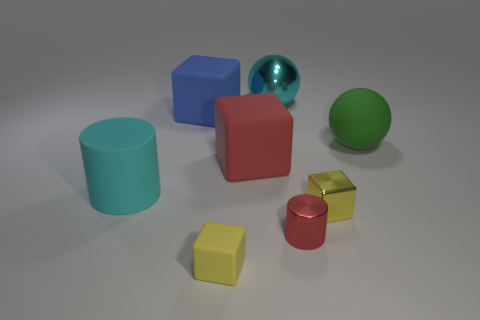Add 1 large blue rubber things. How many objects exist? 9 Subtract all cylinders. How many objects are left? 6 Add 3 large cyan rubber cylinders. How many large cyan rubber cylinders exist? 4 Subtract 1 red cylinders. How many objects are left? 7 Subtract all big yellow shiny things. Subtract all small red metal cylinders. How many objects are left? 7 Add 7 big blue rubber cubes. How many big blue rubber cubes are left? 8 